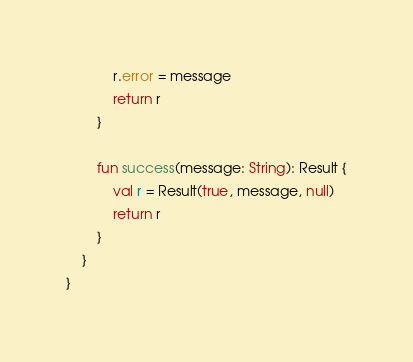<code> <loc_0><loc_0><loc_500><loc_500><_Kotlin_>            r.error = message
            return r
        }

        fun success(message: String): Result {
            val r = Result(true, message, null)
            return r
        }
    }
}
</code> 